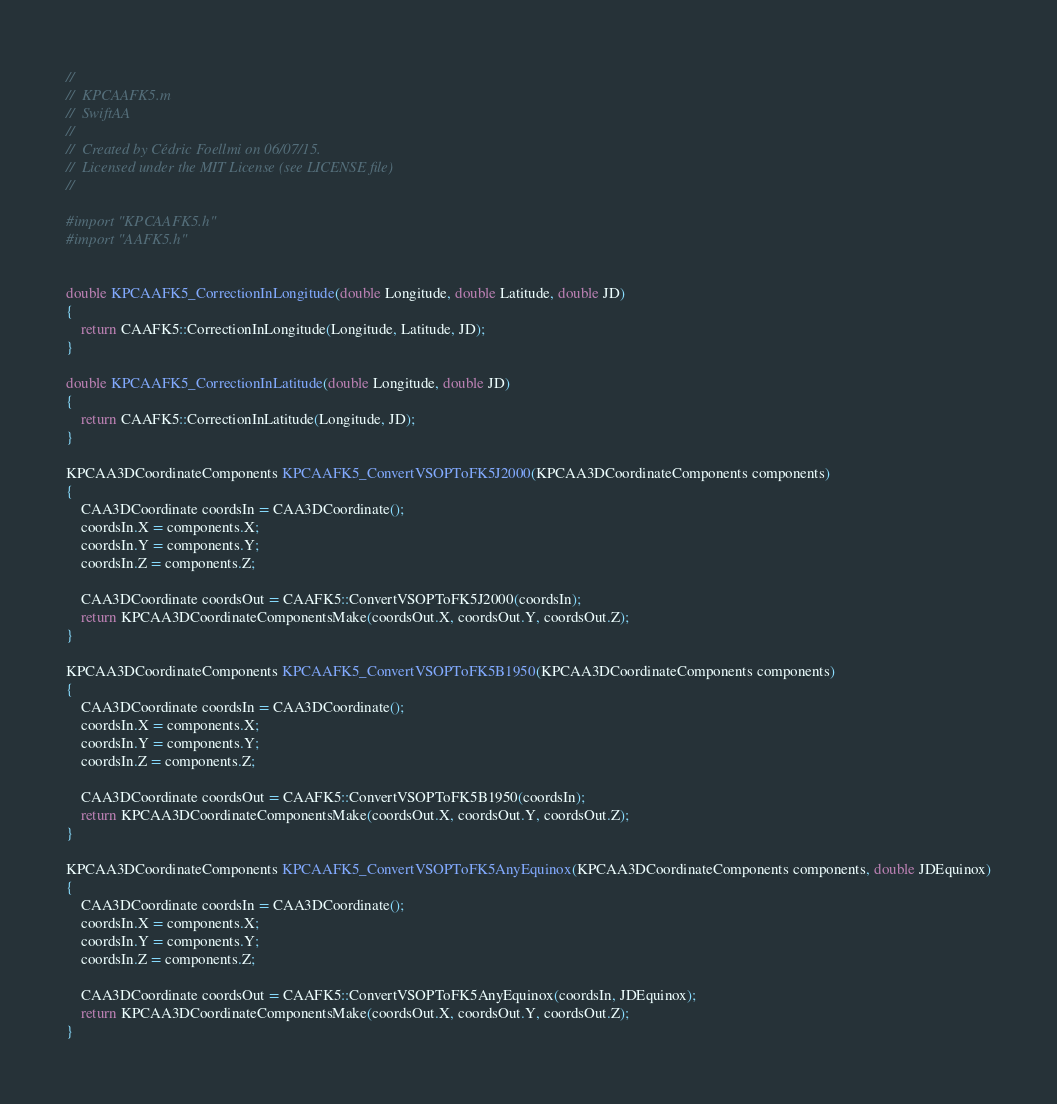<code> <loc_0><loc_0><loc_500><loc_500><_ObjectiveC_>//
//  KPCAAFK5.m
//  SwiftAA
//
//  Created by Cédric Foellmi on 06/07/15.
//  Licensed under the MIT License (see LICENSE file)
//

#import "KPCAAFK5.h"
#import "AAFK5.h"


double KPCAAFK5_CorrectionInLongitude(double Longitude, double Latitude, double JD)
{
    return CAAFK5::CorrectionInLongitude(Longitude, Latitude, JD);
}

double KPCAAFK5_CorrectionInLatitude(double Longitude, double JD)
{
    return CAAFK5::CorrectionInLatitude(Longitude, JD);
}

KPCAA3DCoordinateComponents KPCAAFK5_ConvertVSOPToFK5J2000(KPCAA3DCoordinateComponents components)
{
    CAA3DCoordinate coordsIn = CAA3DCoordinate();
    coordsIn.X = components.X;
    coordsIn.Y = components.Y;
    coordsIn.Z = components.Z;
    
    CAA3DCoordinate coordsOut = CAAFK5::ConvertVSOPToFK5J2000(coordsIn);
    return KPCAA3DCoordinateComponentsMake(coordsOut.X, coordsOut.Y, coordsOut.Z);
}

KPCAA3DCoordinateComponents KPCAAFK5_ConvertVSOPToFK5B1950(KPCAA3DCoordinateComponents components)
{
    CAA3DCoordinate coordsIn = CAA3DCoordinate();
    coordsIn.X = components.X;
    coordsIn.Y = components.Y;
    coordsIn.Z = components.Z;
    
    CAA3DCoordinate coordsOut = CAAFK5::ConvertVSOPToFK5B1950(coordsIn);
    return KPCAA3DCoordinateComponentsMake(coordsOut.X, coordsOut.Y, coordsOut.Z);
}

KPCAA3DCoordinateComponents KPCAAFK5_ConvertVSOPToFK5AnyEquinox(KPCAA3DCoordinateComponents components, double JDEquinox)
{
    CAA3DCoordinate coordsIn = CAA3DCoordinate();
    coordsIn.X = components.X;
    coordsIn.Y = components.Y;
    coordsIn.Z = components.Z;
    
    CAA3DCoordinate coordsOut = CAAFK5::ConvertVSOPToFK5AnyEquinox(coordsIn, JDEquinox);
    return KPCAA3DCoordinateComponentsMake(coordsOut.X, coordsOut.Y, coordsOut.Z);
}

</code> 